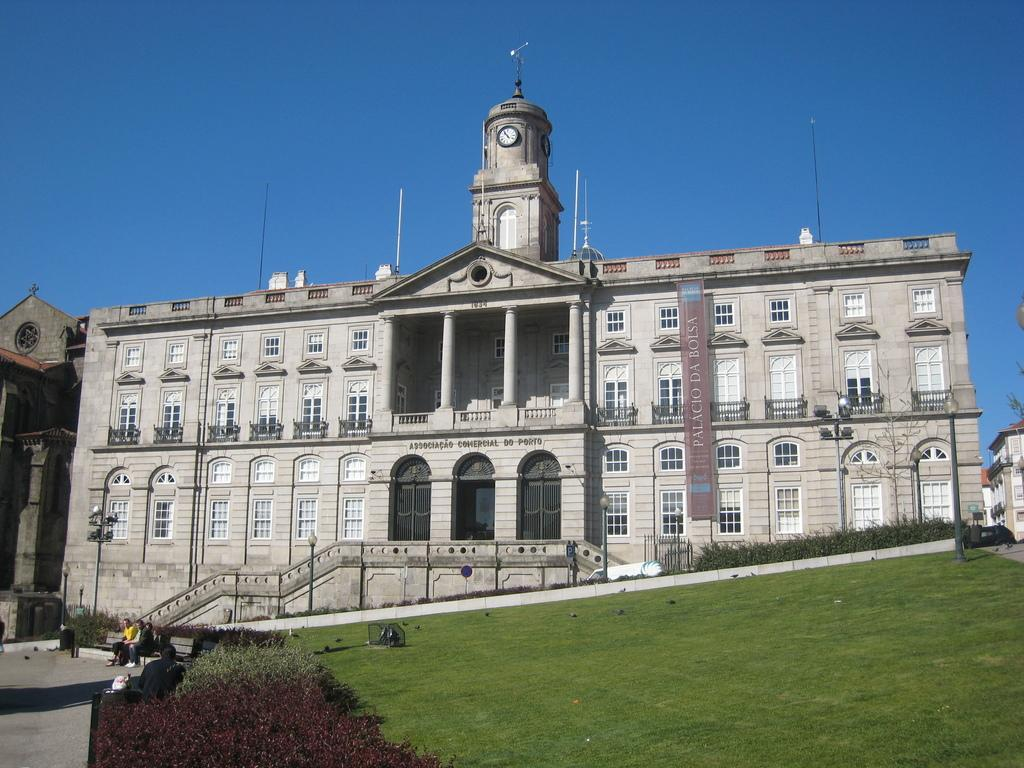What type of structure is visible in the image? There is a building in the image. What type of vegetation is present in the image? There is grass and plants in the image. What are the people in the image doing? People are sitting on a bench in the image. What type of lighting is present in the image? Pole lights are present in the image. What can be seen in the background of the image? The sky is visible in the background of the image. What type of quiver is being used by the person in the image? There is no person using a quiver in the image; it is not present. How many times does the person smash the building in the image? There is no person smashing the building in the image; it is not present. 